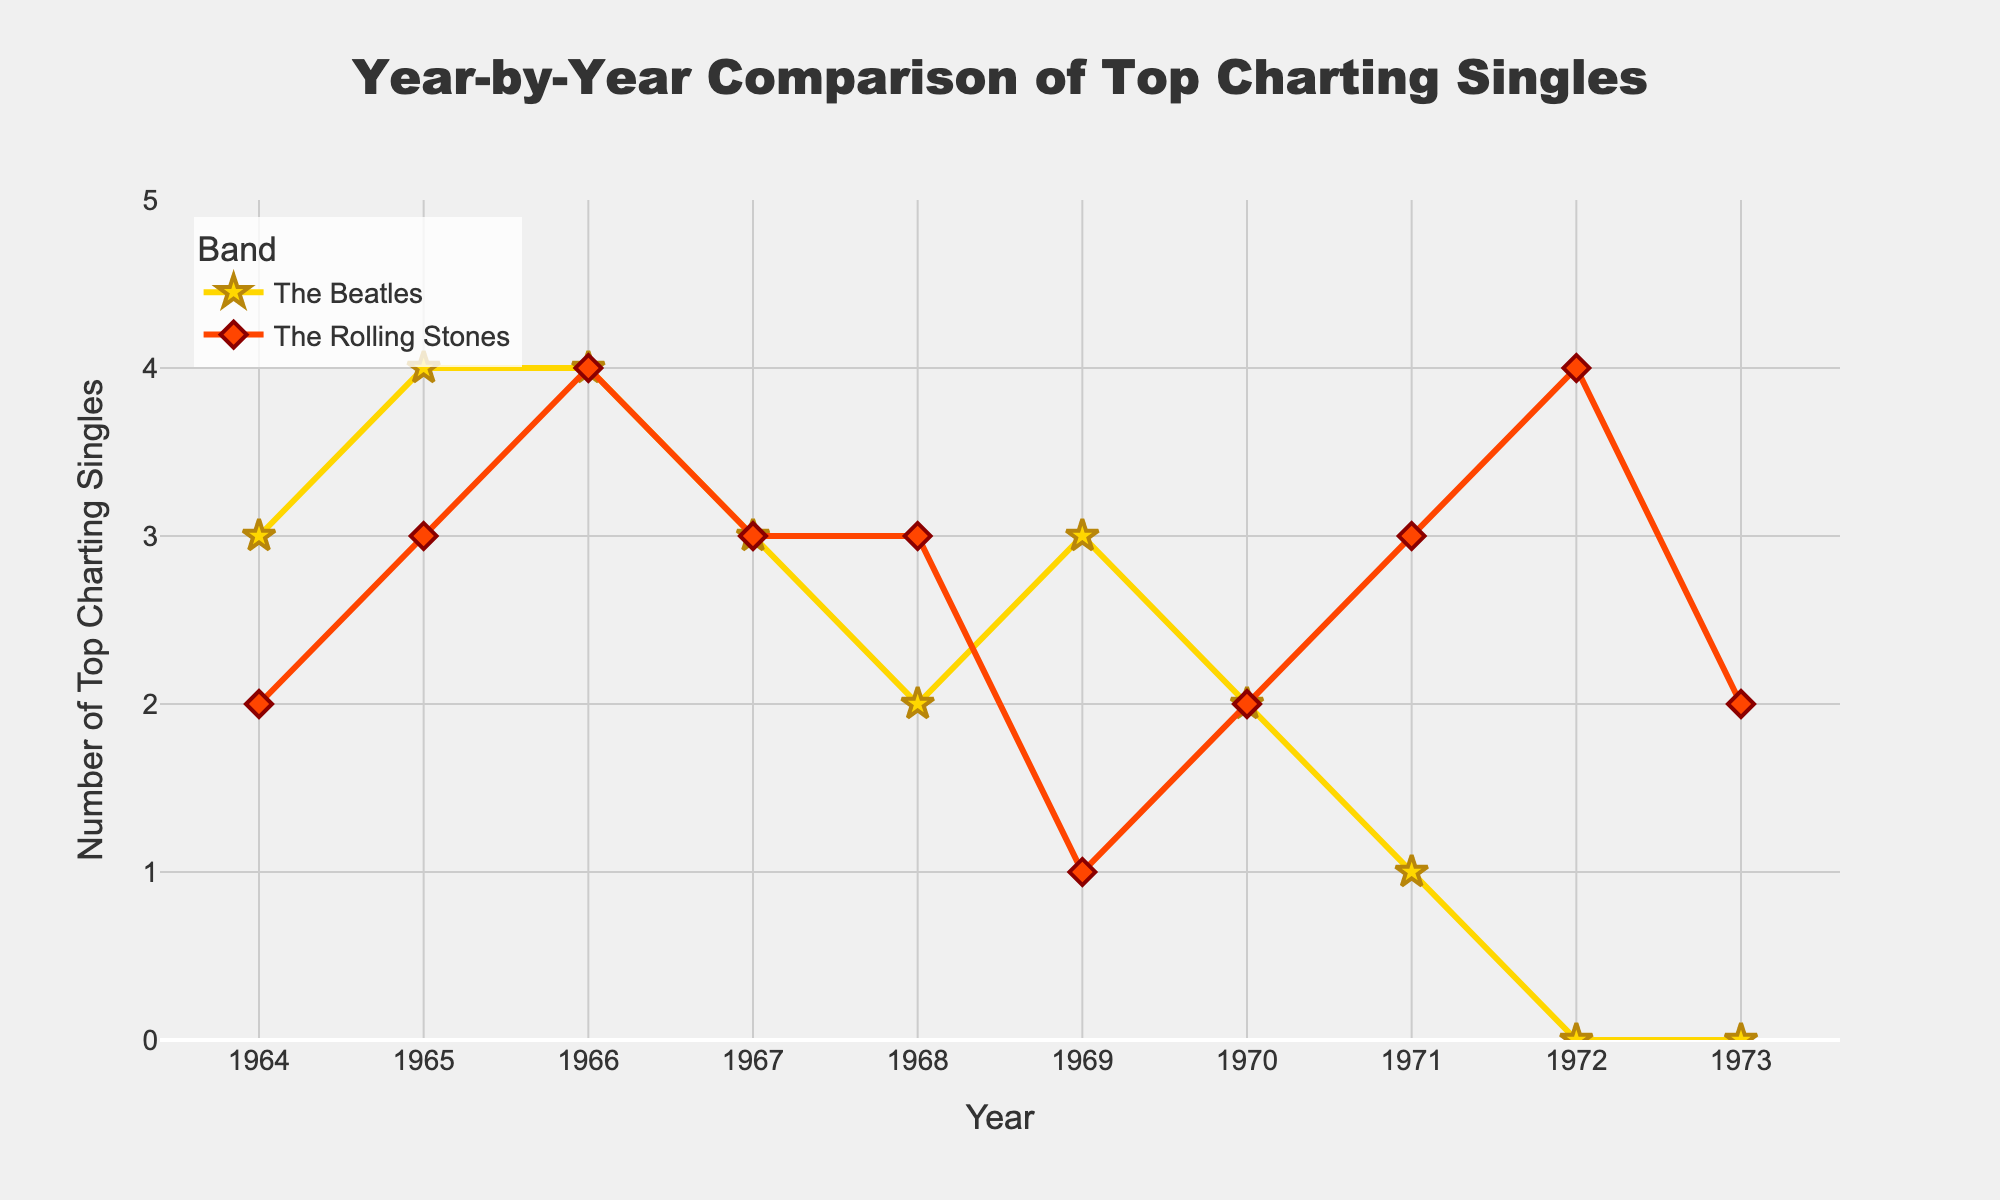What's the title of the plot? The title is displayed at the top of the plot. It reads "Year-by-Year Comparison of Top Charting Singles".
Answer: Year-by-Year Comparison of Top Charting Singles In which year did The Beatles have the most top charting singles? Look for the highest point in the plot for The Beatles (gold line with star markers). The highest value is 4 in 1965 and 1966.
Answer: 1965 and 1966 How many years did The Rolling Stones have more top charting singles than The Beatles? Compare the values of the two plots for each year. The Rolling Stones (red line with diamond markers) have more top singles in 1968, 1969, 1971, 1972, and 1973.
Answer: 5 years What is the total number of top charting singles for The Beatles from 1964 to 1973? Sum the values for The Beatles from 1964 to 1973. That's 3 + 4 + 4 + 3 + 2 + 3 + 2 + 1 + 0 + 0 = 22.
Answer: 22 In what year do The Beatles and The Rolling Stones have the same number of top charting singles? Look for points where the values of both lines match. This happens in 1966 (4) and 1967 (3).
Answer: 1966 and 1967 Which band had the higher average number of top charting singles over the period? Compute the averages: Beatles (22 top singles/10 years) and Rolling Stones (27 top singles/10 years). Compare them. The averages are 2.2 for The Beatles and 2.7 for The Rolling Stones.
Answer: The Rolling Stones In which year do The Rolling Stones have their highest number of top charting singles? Look for the highest point in the plot for The Rolling Stones. The highest value is 4 in 1972.
Answer: 1972 How does the number of top charting singles for both bands change in 1968? Compare 1967 to 1968 for both bands. For The Beatles: 3 to 2 (decreases by 1). For The Rolling Stones: 3 to 3 (no change).
Answer: The Beatles decrease by 1, The Rolling Stones stay the same 